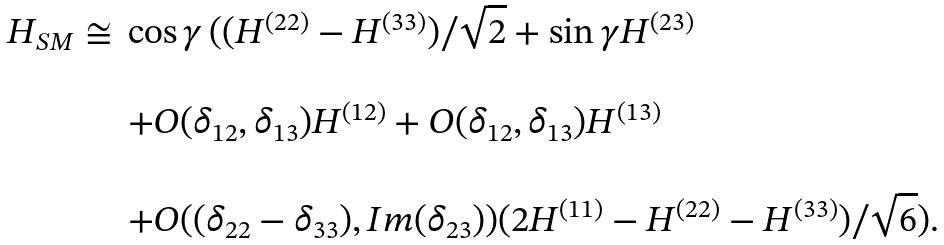<formula> <loc_0><loc_0><loc_500><loc_500>\begin{array} { l l } H _ { S M } \cong & \cos \gamma \, ( ( H ^ { ( 2 2 ) } - H ^ { ( 3 3 ) } ) / \sqrt { 2 } + \sin \gamma H ^ { ( 2 3 ) } \\ \\ & + O ( \delta _ { 1 2 } , \delta _ { 1 3 } ) H ^ { ( 1 2 ) } + O ( \delta _ { 1 2 } , \delta _ { 1 3 } ) H ^ { ( 1 3 ) } \\ \\ & + O ( ( \delta _ { 2 2 } - \delta _ { 3 3 } ) , I m ( \delta _ { 2 3 } ) ) ( 2 H ^ { ( 1 1 ) } - H ^ { ( 2 2 ) } - H ^ { ( 3 3 ) } ) / \sqrt { 6 } ) . \end{array}</formula> 